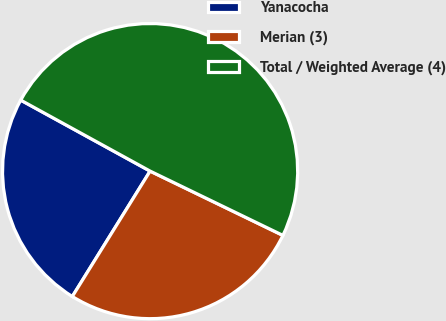Convert chart to OTSL. <chart><loc_0><loc_0><loc_500><loc_500><pie_chart><fcel>Yanacocha<fcel>Merian (3)<fcel>Total / Weighted Average (4)<nl><fcel>24.15%<fcel>26.66%<fcel>49.19%<nl></chart> 